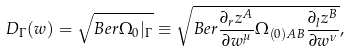<formula> <loc_0><loc_0><loc_500><loc_500>D _ { \Gamma } ( w ) = \sqrt { B e r \Omega _ { 0 } | _ { \Gamma } } \equiv \sqrt { B e r \frac { \partial _ { r } z ^ { A } } { \partial w ^ { \mu } } \Omega _ { ( 0 ) A B } \frac { \partial _ { l } z ^ { B } } { \partial w ^ { \nu } } } ,</formula> 